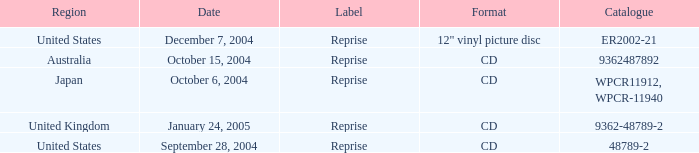Identify the tag for january 24, 200 Reprise. 